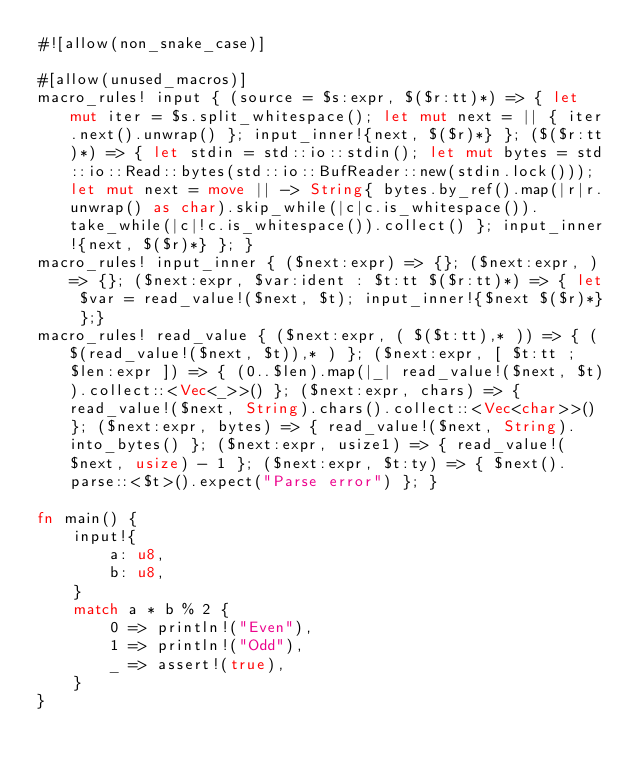Convert code to text. <code><loc_0><loc_0><loc_500><loc_500><_Rust_>#![allow(non_snake_case)]

#[allow(unused_macros)]
macro_rules! input { (source = $s:expr, $($r:tt)*) => { let mut iter = $s.split_whitespace(); let mut next = || { iter.next().unwrap() }; input_inner!{next, $($r)*} }; ($($r:tt)*) => { let stdin = std::io::stdin(); let mut bytes = std::io::Read::bytes(std::io::BufReader::new(stdin.lock())); let mut next = move || -> String{ bytes.by_ref().map(|r|r.unwrap() as char).skip_while(|c|c.is_whitespace()).take_while(|c|!c.is_whitespace()).collect() }; input_inner!{next, $($r)*} }; }
macro_rules! input_inner { ($next:expr) => {}; ($next:expr, ) => {}; ($next:expr, $var:ident : $t:tt $($r:tt)*) => { let $var = read_value!($next, $t); input_inner!{$next $($r)*} };}
macro_rules! read_value { ($next:expr, ( $($t:tt),* )) => { ( $(read_value!($next, $t)),* ) }; ($next:expr, [ $t:tt ; $len:expr ]) => { (0..$len).map(|_| read_value!($next, $t)).collect::<Vec<_>>() }; ($next:expr, chars) => { read_value!($next, String).chars().collect::<Vec<char>>() }; ($next:expr, bytes) => { read_value!($next, String).into_bytes() }; ($next:expr, usize1) => { read_value!($next, usize) - 1 }; ($next:expr, $t:ty) => { $next().parse::<$t>().expect("Parse error") }; }

fn main() {
    input!{
        a: u8,
        b: u8,
    }
    match a * b % 2 {
        0 => println!("Even"),
        1 => println!("Odd"),
        _ => assert!(true),
    }
}
</code> 